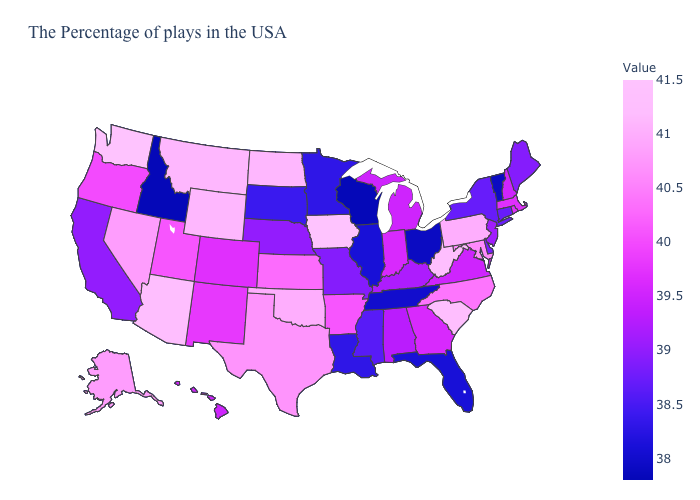Which states have the lowest value in the Northeast?
Answer briefly. Vermont. Which states have the lowest value in the USA?
Write a very short answer. Wisconsin, Idaho. Among the states that border New Mexico , which have the highest value?
Give a very brief answer. Arizona. Does Wyoming have the lowest value in the West?
Quick response, please. No. Which states have the highest value in the USA?
Write a very short answer. Iowa, Washington. 